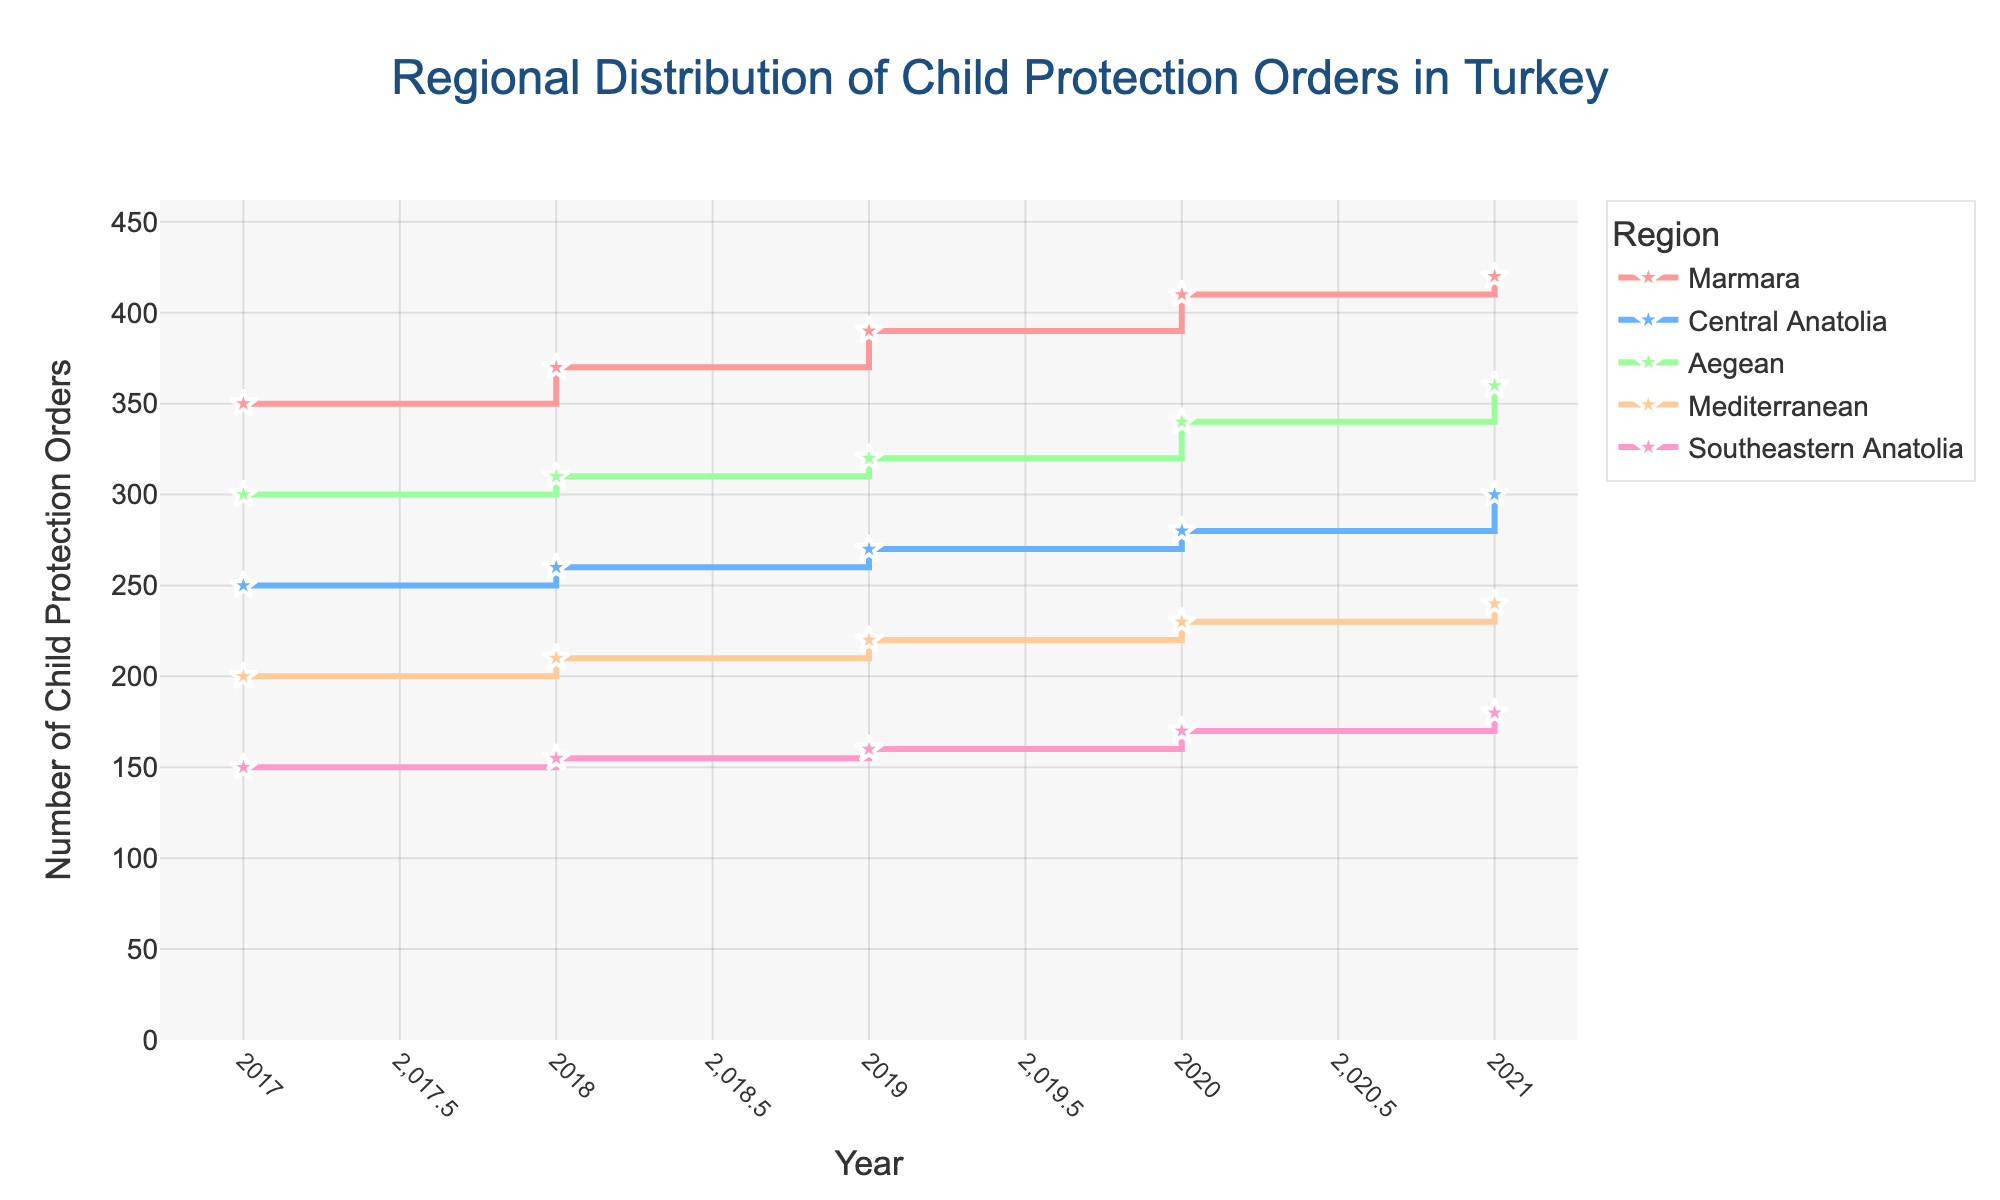What is the title of the figure? The title is located at the top center of the figure and is used to describe what the plot is about.
Answer: Regional Distribution of Child Protection Orders in Turkey How many regions are represented in the figure? By observing the legend, we can count the number of different regions mentioned.
Answer: 5 Which region had the highest number of child protection orders in 2021? By checking the data points for 2021 on the x-axis and comparing the y-values across regions, the highest y-value indicates the highest number of orders.
Answer: Marmara What is the average number of child protection orders in the Aegean region across all years? Sum the number of orders for each year in the Aegean region (300 + 310 + 320 + 340 + 360) and divide by the number of years (5).
Answer: 326 Which region showed the least increase in child protection orders from 2017 to 2021? By comparing the number of child protection orders from 2017 to 2021 for each region and calculating the differences, we identify the smallest difference.
Answer: Southeastern Anatolia Compare the number of child protection orders between Marmara and Central Anatolia in 2020. Which region had more and by how much? Identify the values for each region in 2020 and subtract the Central Anatolia value from the Marmara value.
Answer: Marmara had 130 more orders than Central Anatolia What pattern in the trend of child protection orders can be observed across all regions from 2017 to 2021? Look for the general direction of the lines for all regions over the years from 2017 to 2021.
Answer: An increasing trend What is the total number of child protection orders in the Mediterranean region over the five years? Add the number of orders for each year in the Mediterranean region (200 + 210 + 220 + 230 + 240).
Answer: 1100 Which region had the smallest number of child protection orders in 2018, and how many were there? By comparing the data points for 2018 across all regions, identify the smallest y-value.
Answer: Southeastern Anatolia, 155 